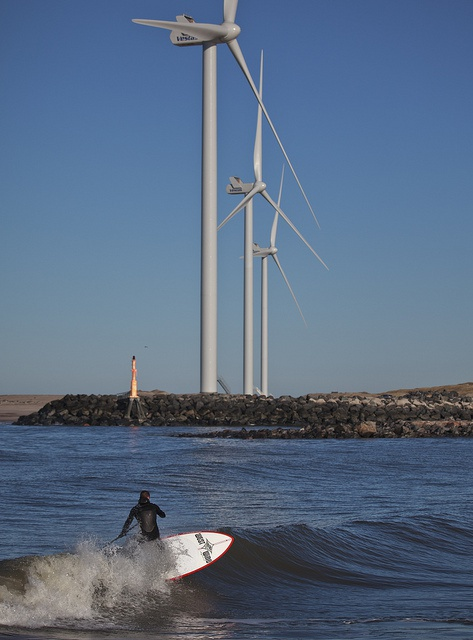Describe the objects in this image and their specific colors. I can see surfboard in blue, lightgray, darkgray, gray, and brown tones and people in blue, black, and gray tones in this image. 